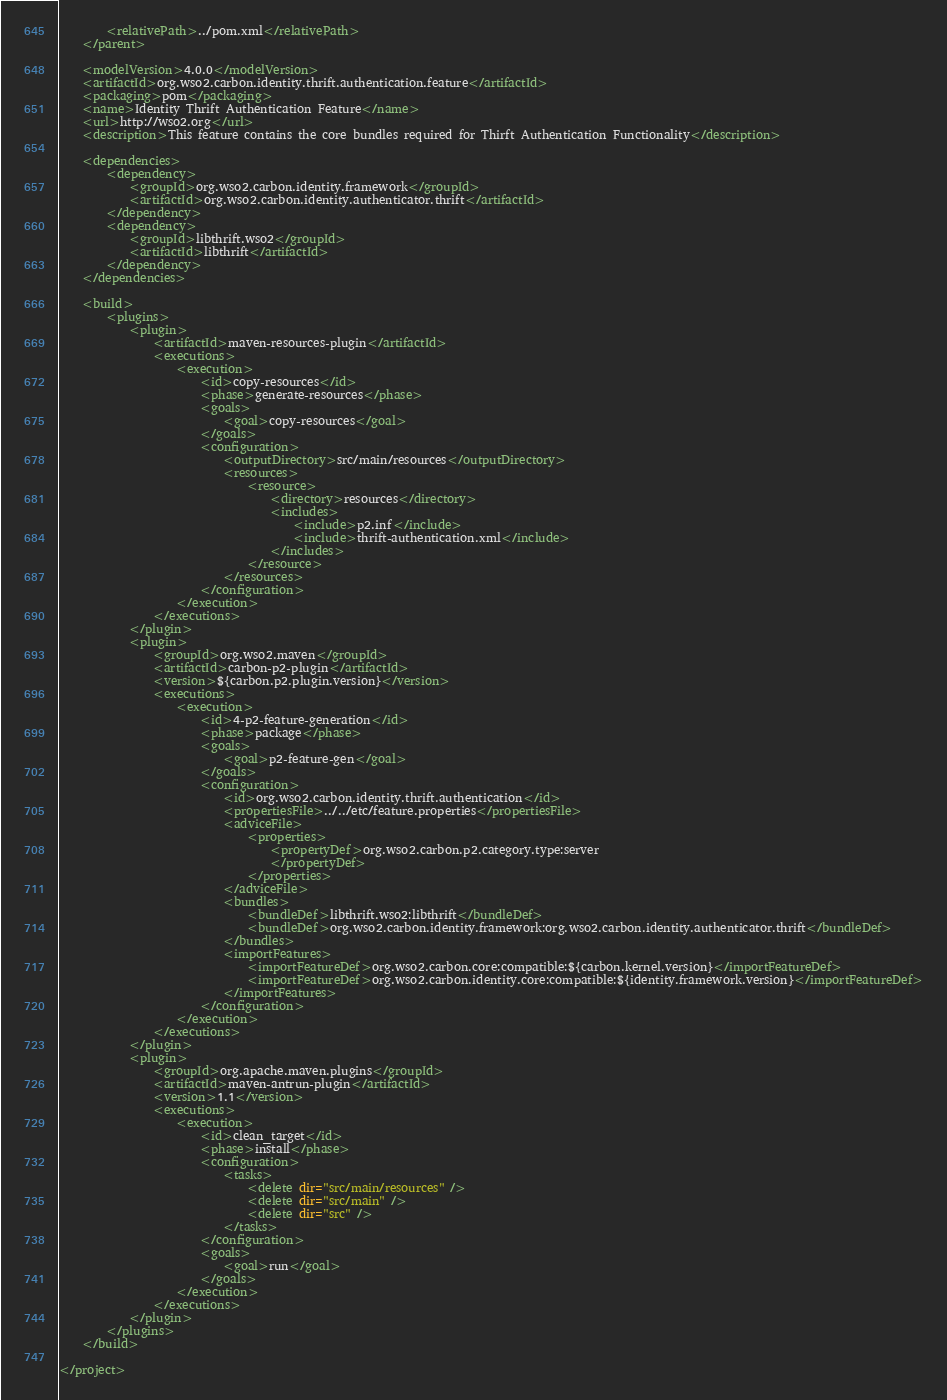<code> <loc_0><loc_0><loc_500><loc_500><_XML_>        <relativePath>../pom.xml</relativePath>
    </parent>

    <modelVersion>4.0.0</modelVersion>
    <artifactId>org.wso2.carbon.identity.thrift.authentication.feature</artifactId>
    <packaging>pom</packaging>
    <name>Identity Thrift Authentication Feature</name>
    <url>http://wso2.org</url>
    <description>This feature contains the core bundles required for Thirft Authentication Functionality</description>

    <dependencies>
        <dependency>
            <groupId>org.wso2.carbon.identity.framework</groupId>
            <artifactId>org.wso2.carbon.identity.authenticator.thrift</artifactId>
        </dependency>
        <dependency>
            <groupId>libthrift.wso2</groupId>
            <artifactId>libthrift</artifactId>
        </dependency>
    </dependencies>

    <build>
        <plugins>
            <plugin>
                <artifactId>maven-resources-plugin</artifactId>
                <executions>
                    <execution>
                        <id>copy-resources</id>
                        <phase>generate-resources</phase>
                        <goals>
                            <goal>copy-resources</goal>
                        </goals>
                        <configuration>
                            <outputDirectory>src/main/resources</outputDirectory>
                            <resources>
                                <resource>
                                    <directory>resources</directory>
                                    <includes>
                                        <include>p2.inf</include>
                                        <include>thrift-authentication.xml</include>
                                    </includes>
                                </resource>
                            </resources>
                        </configuration>
                    </execution>
                </executions>
            </plugin>
            <plugin>
                <groupId>org.wso2.maven</groupId>
                <artifactId>carbon-p2-plugin</artifactId>
                <version>${carbon.p2.plugin.version}</version>
                <executions>
                    <execution>
                        <id>4-p2-feature-generation</id>
                        <phase>package</phase>
                        <goals>
                            <goal>p2-feature-gen</goal>
                        </goals>
                        <configuration>
                            <id>org.wso2.carbon.identity.thrift.authentication</id>
                            <propertiesFile>../../etc/feature.properties</propertiesFile>
                            <adviceFile>
                                <properties>
                                    <propertyDef>org.wso2.carbon.p2.category.type:server
                                    </propertyDef>
                                </properties>
                            </adviceFile>
                            <bundles>
                                <bundleDef>libthrift.wso2:libthrift</bundleDef>
                                <bundleDef>org.wso2.carbon.identity.framework:org.wso2.carbon.identity.authenticator.thrift</bundleDef>
                            </bundles>
                            <importFeatures>
                                <importFeatureDef>org.wso2.carbon.core:compatible:${carbon.kernel.version}</importFeatureDef>
                                <importFeatureDef>org.wso2.carbon.identity.core:compatible:${identity.framework.version}</importFeatureDef>
                            </importFeatures>
                        </configuration>
                    </execution>
                </executions>
            </plugin>
            <plugin>
                <groupId>org.apache.maven.plugins</groupId>
                <artifactId>maven-antrun-plugin</artifactId>
                <version>1.1</version>
                <executions>
                    <execution>
                        <id>clean_target</id>
                        <phase>install</phase>
                        <configuration>
                            <tasks>
                                <delete dir="src/main/resources" />
                                <delete dir="src/main" />
                                <delete dir="src" />
                            </tasks>
                        </configuration>
                        <goals>
                            <goal>run</goal>
                        </goals>
                    </execution>
                </executions>
            </plugin>
        </plugins>
    </build>

</project>
</code> 